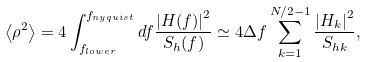<formula> <loc_0><loc_0><loc_500><loc_500>\left < \rho ^ { 2 } \right > = 4 \int _ { f _ { l o w e r } } ^ { f _ { n y q u i s t } } d f \frac { { | H ( f ) | } ^ { 2 } } { S _ { h } ( f ) } \simeq 4 \Delta f \sum _ { k = 1 } ^ { N / 2 - 1 } \frac { { | H _ { k } | } ^ { 2 } } { S _ { h k } } ,</formula> 